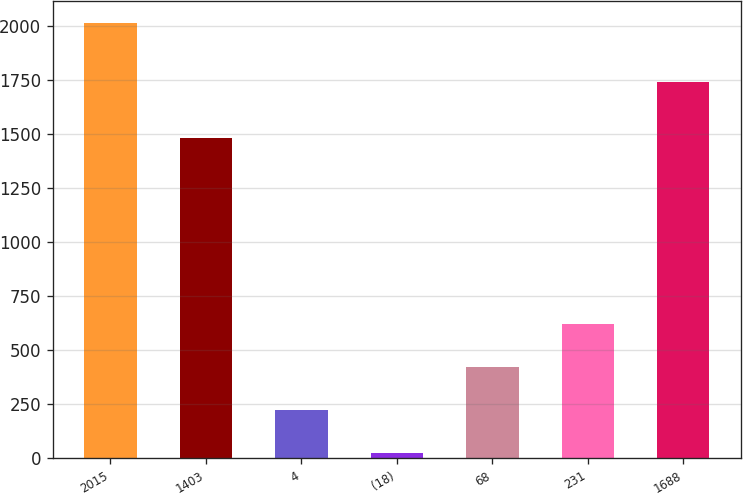Convert chart. <chart><loc_0><loc_0><loc_500><loc_500><bar_chart><fcel>2015<fcel>1403<fcel>4<fcel>(18)<fcel>68<fcel>231<fcel>1688<nl><fcel>2014<fcel>1479<fcel>223.9<fcel>25<fcel>422.8<fcel>621.7<fcel>1741<nl></chart> 